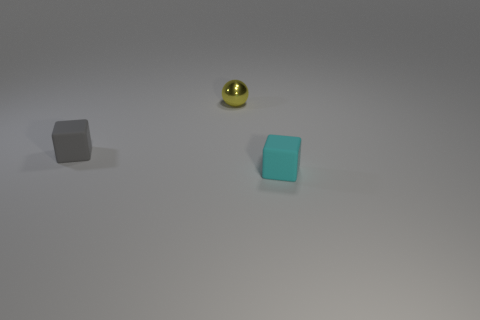There is a rubber object to the left of the small rubber thing that is to the right of the tiny matte thing that is to the left of the yellow object; what color is it?
Your answer should be very brief. Gray. There is a block that is behind the small cube in front of the tiny gray rubber cube; what color is it?
Your answer should be very brief. Gray. Is the number of small yellow shiny balls that are behind the small yellow sphere greater than the number of tiny gray things that are left of the gray matte cube?
Offer a very short reply. No. Is the material of the tiny block on the right side of the sphere the same as the small block that is to the left of the shiny thing?
Your response must be concise. Yes. There is a small yellow thing; are there any small rubber cubes behind it?
Ensure brevity in your answer.  No. What number of purple objects are tiny rubber cubes or large cubes?
Make the answer very short. 0. Does the tiny gray thing have the same material as the thing right of the small yellow metallic object?
Give a very brief answer. Yes. What size is the other matte object that is the same shape as the gray thing?
Your answer should be compact. Small. What material is the tiny ball?
Your answer should be compact. Metal. What is the material of the tiny thing that is in front of the small matte thing behind the block that is to the right of the shiny object?
Your response must be concise. Rubber. 